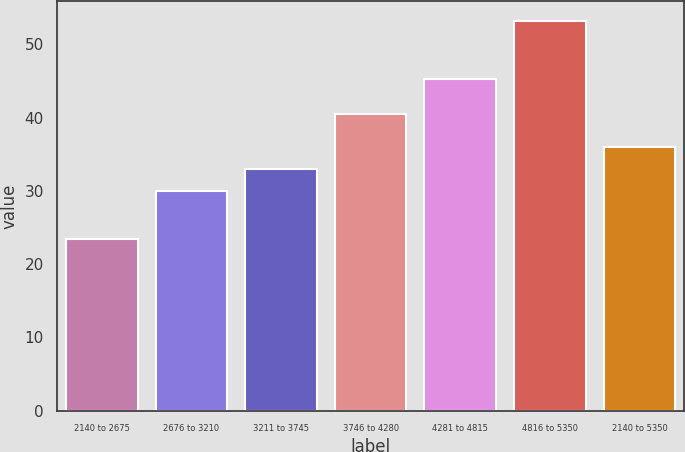<chart> <loc_0><loc_0><loc_500><loc_500><bar_chart><fcel>2140 to 2675<fcel>2676 to 3210<fcel>3211 to 3745<fcel>3746 to 4280<fcel>4281 to 4815<fcel>4816 to 5350<fcel>2140 to 5350<nl><fcel>23.42<fcel>29.99<fcel>32.97<fcel>40.44<fcel>45.25<fcel>53.19<fcel>35.95<nl></chart> 